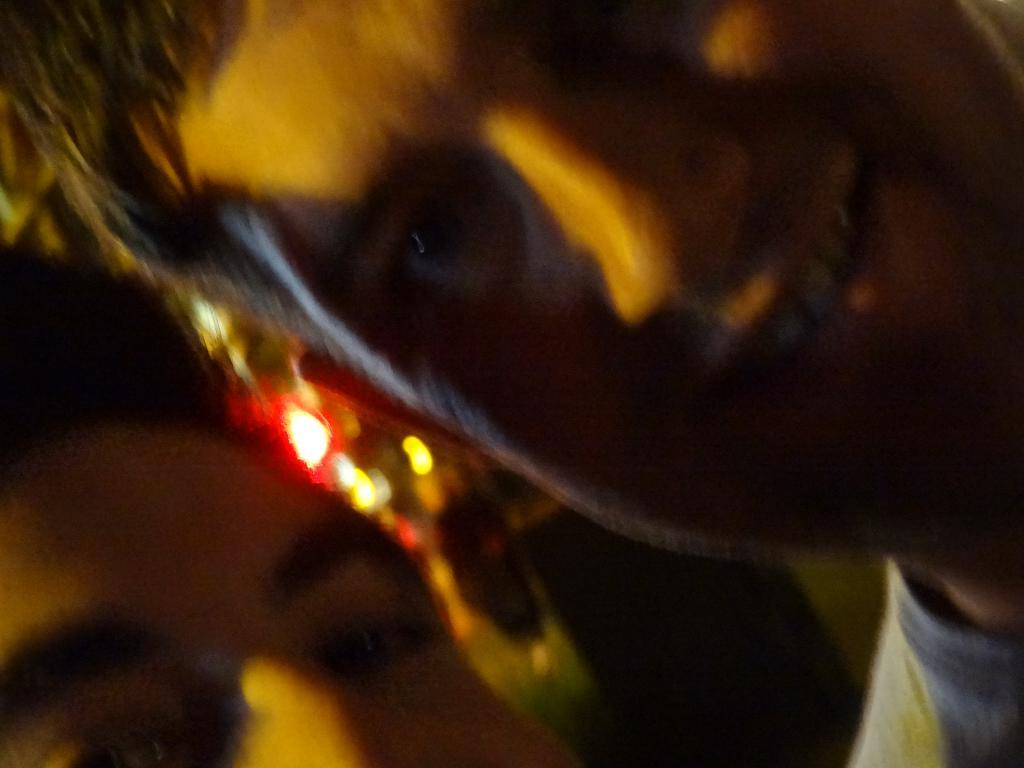How many people are present in the image? There are two persons in the image. What can be seen in addition to the people in the image? Lights are visible in the image. Where is the frog sitting in the image? There is no frog present in the image. What type of glove is being worn by one of the persons in the image? There is no information about gloves in the image. 